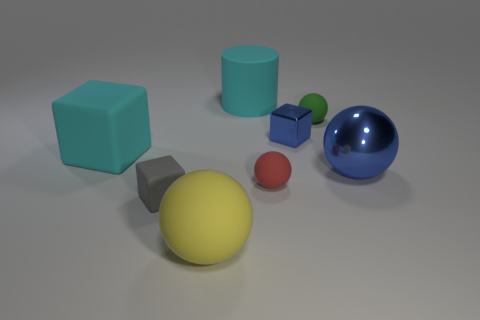How would you describe the setting of this image? The setting appears to be a simple, uncluttered space with a neutral background, which brings the focus squarely on the assorted shapes and colors of the objects. It's reminiscent of a controlled environment you might find in a 3D modeling software or an experimental setup. 